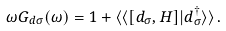<formula> <loc_0><loc_0><loc_500><loc_500>\omega G _ { d \sigma } ( \omega ) = 1 + \langle \langle [ d _ { \sigma } , H ] | d _ { \sigma } ^ { \dag } \rangle \rangle \, .</formula> 